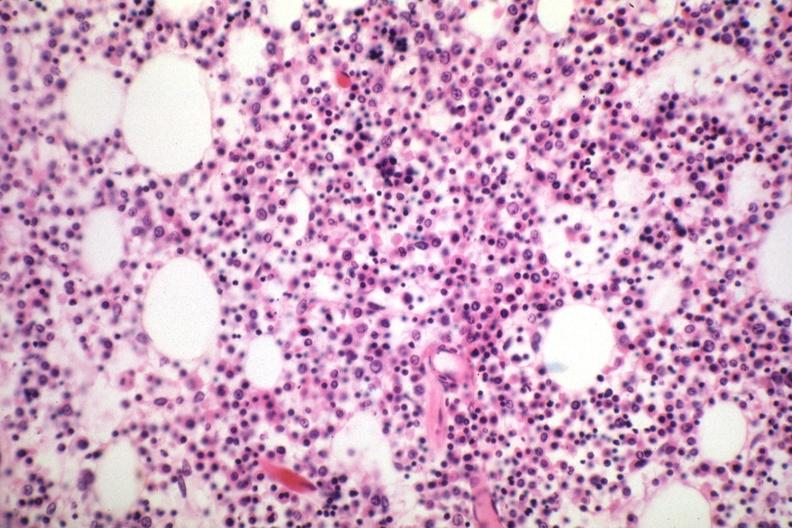s small intestine present?
Answer the question using a single word or phrase. No 